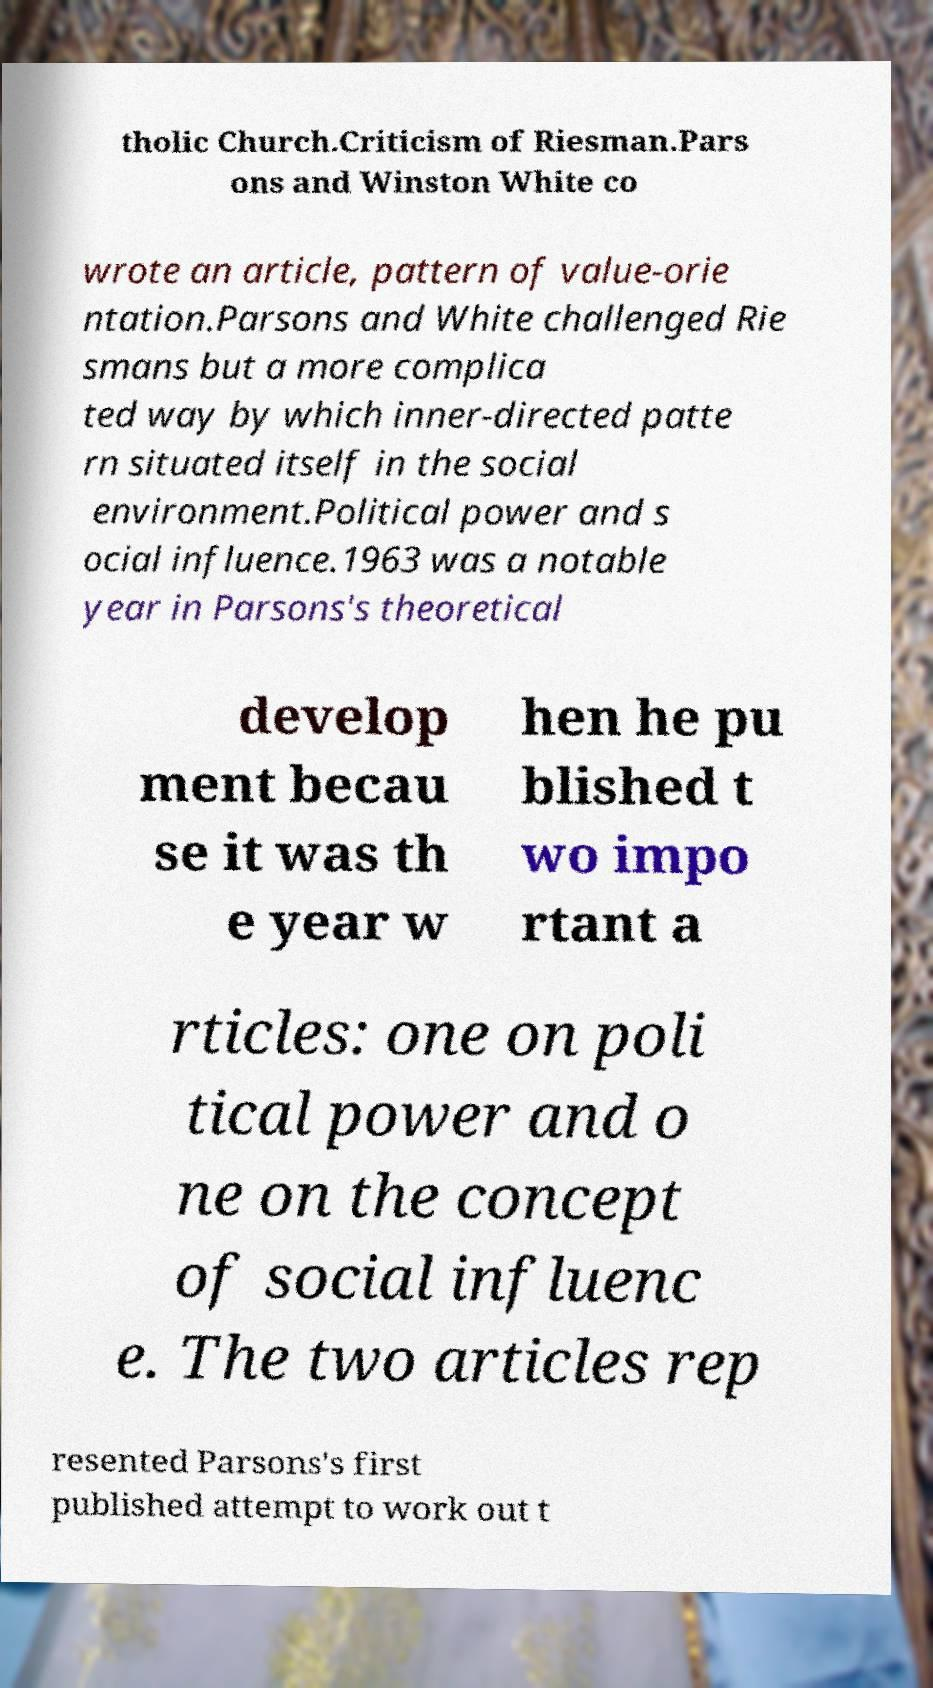Please read and relay the text visible in this image. What does it say? tholic Church.Criticism of Riesman.Pars ons and Winston White co wrote an article, pattern of value-orie ntation.Parsons and White challenged Rie smans but a more complica ted way by which inner-directed patte rn situated itself in the social environment.Political power and s ocial influence.1963 was a notable year in Parsons's theoretical develop ment becau se it was th e year w hen he pu blished t wo impo rtant a rticles: one on poli tical power and o ne on the concept of social influenc e. The two articles rep resented Parsons's first published attempt to work out t 